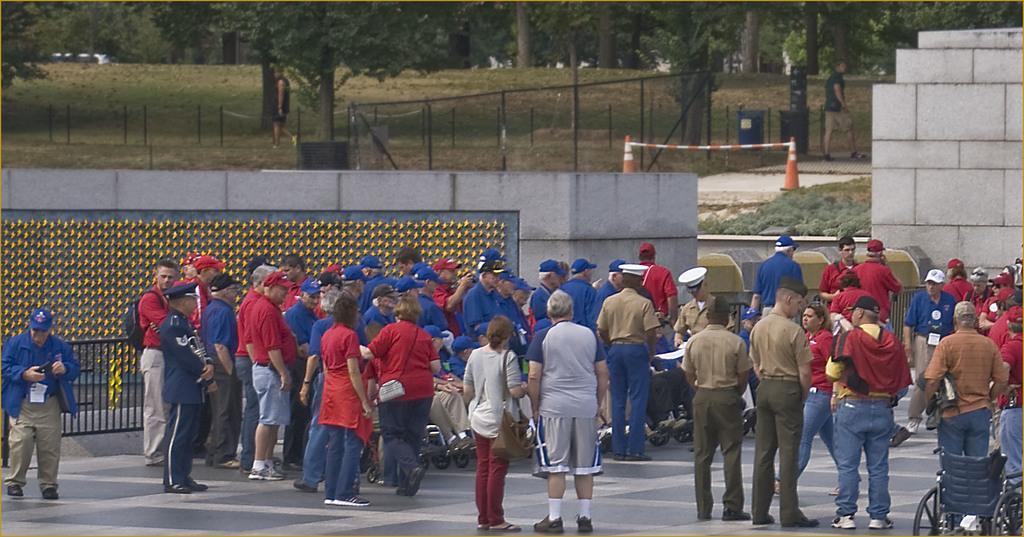In one or two sentences, can you explain what this image depicts? In this image, we can see a crowd standing and wearing clothes. There is a wall and divider cones in the middle of the image. There are some trees at the top of the image. There is a wheelchair in the bottom right of the image. 